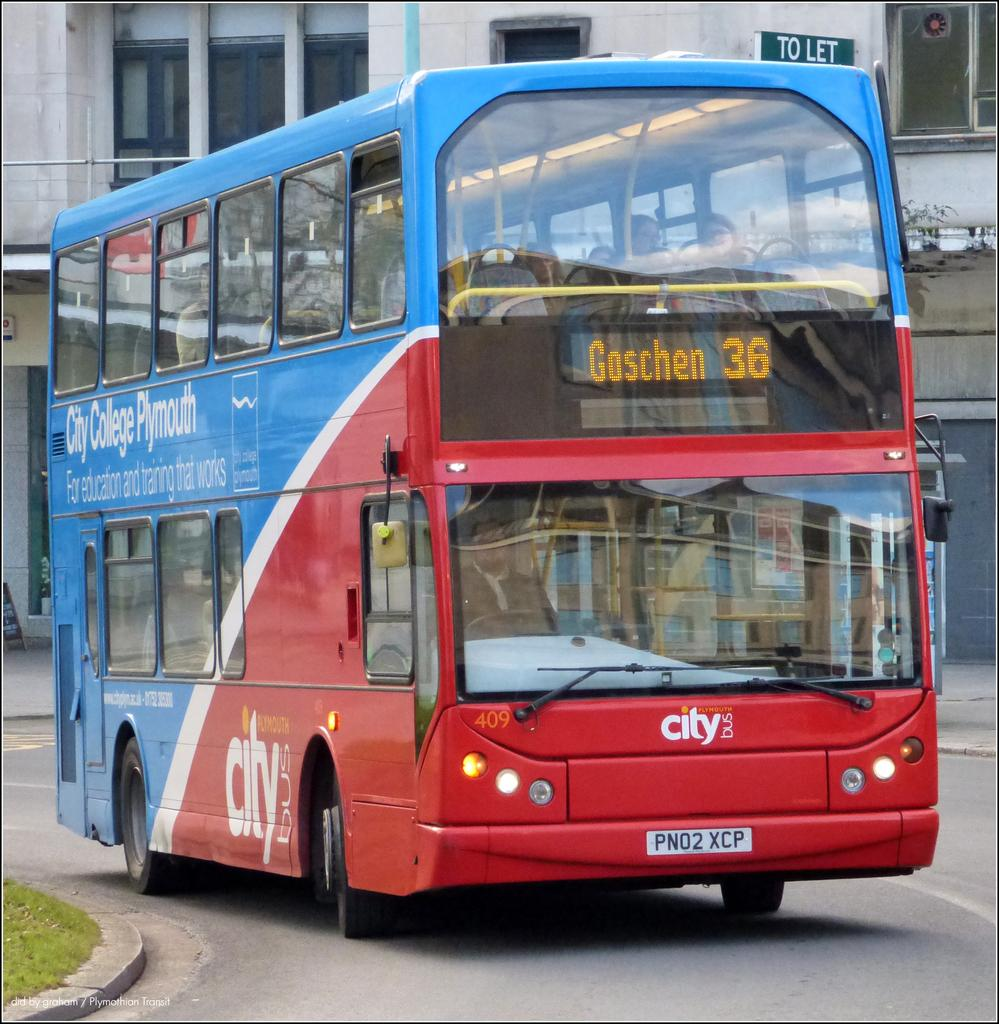<image>
Share a concise interpretation of the image provided. A double decker bus services a location known as City College Plymouth. 